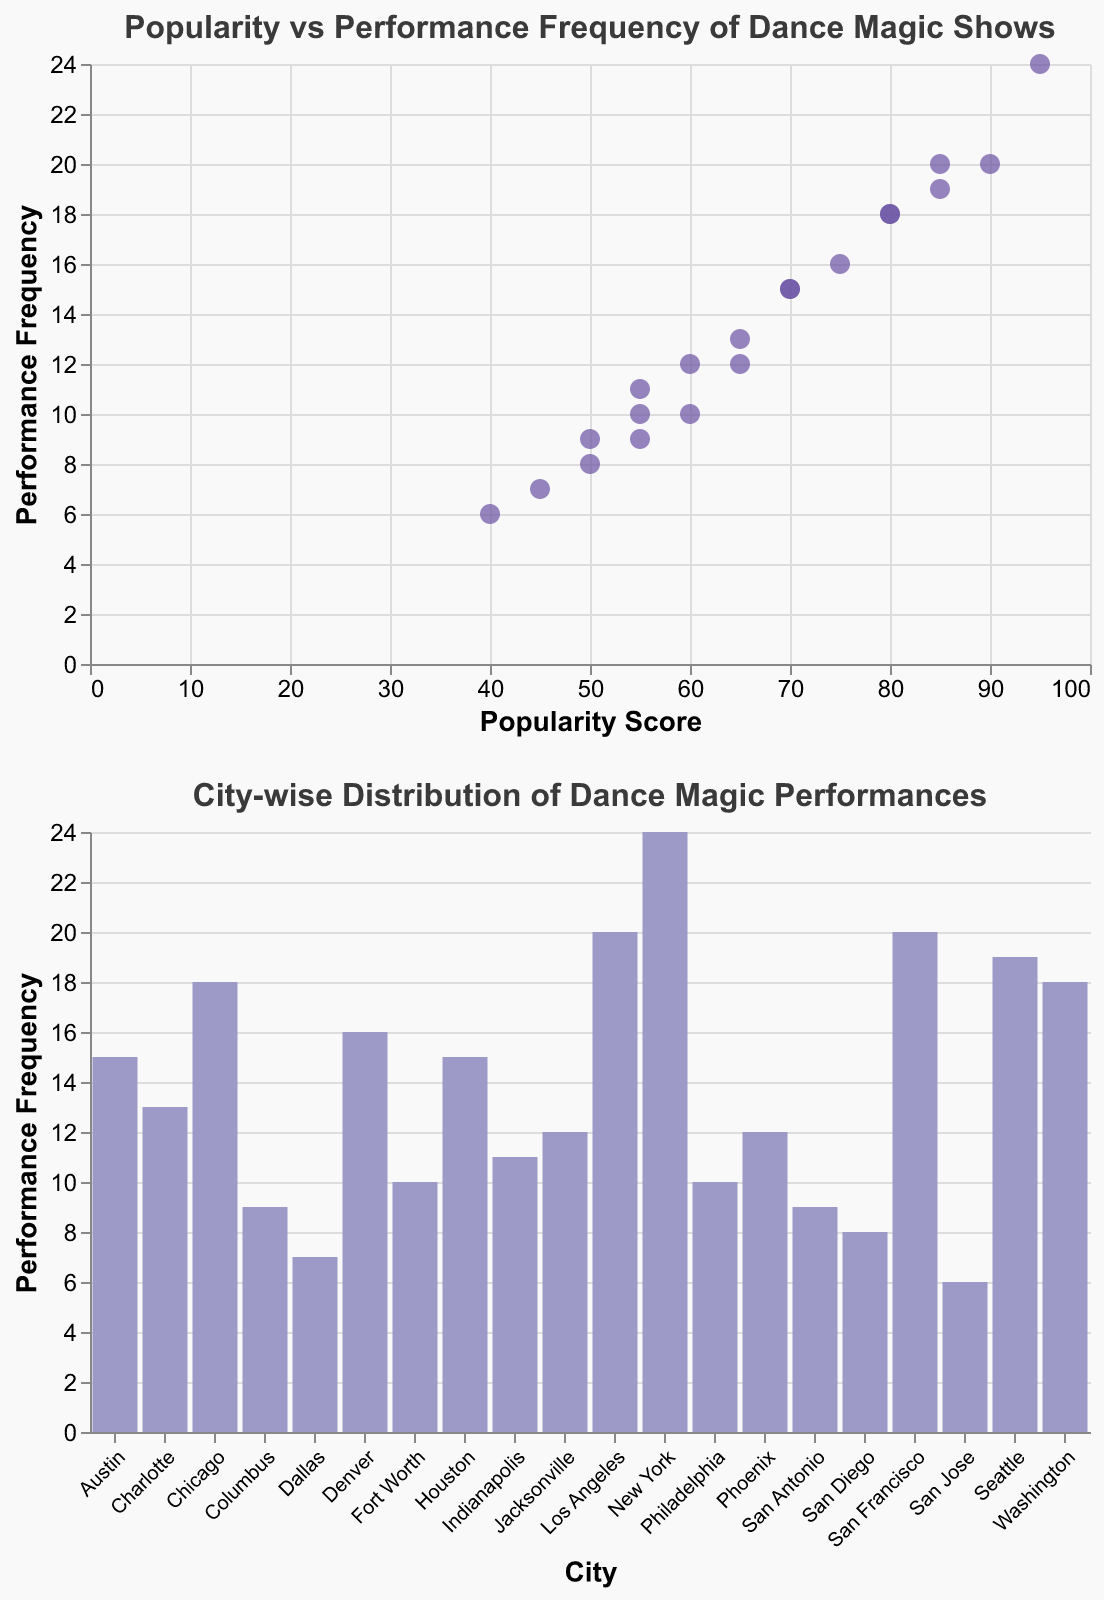What's the city with the highest popularity score? The scatter plot shows various cities with their corresponding popularity scores and performance frequencies. The highest popularity score visible is 95, which belongs to New York.
Answer: New York Which city has the most frequent performances? The city with the highest performance frequency can be identified from the scatter plot. The city reaching the highest y-axis value of 24 is New York.
Answer: New York How many cities have a performance frequency of less than 10? From the scatter plot, the cities with a performance frequency less than 10 are San Antonio, San Diego, Dallas, San Jose, and Columbus. Counting these gives a total of 5 cities.
Answer: 5 Which city has both a high popularity score and performance frequency but isn't the highest in either category? From the scatter plot, Seattle has a popularity score of 85 and a performance frequency of 19. While these values are high, they are not the highest in their respective categories.
Answer: Seattle What is the average performance frequency of cities having popularity scores above 80? Cities with popularity scores above 80 are New York (24), Los Angeles (20), San Francisco (20), Seattle (19), and Washington (18). Summing their frequencies: 24 + 20 + 20 + 19 + 18 = 101. The average is 101/5.
Answer: 20.2 Which city with a popularity score below 60 has the highest performance frequency? From the scatter plot or the table, Philadelphia has a popularity score of 60 with a performance frequency of 10. All other cities below 60 have lower frequencies.
Answer: Philadelphia Compare the performance frequencies of Austin and Denver. Which city has more performances? Austin has a performance frequency of 15, whereas Denver has a performance frequency of 16. Therefore, Denver has more performances.
Answer: Denver Which city with a popularity score of exactly 60 has more performances, Jacksonville or Philadelphia? Both cities have a popularity score of 60. Jacksonville has 12 performances, while Philadelphia has 10. Thus, Jacksonville has more performances.
Answer: Jacksonville How many cities have both a popularity score and performance frequency above 15? From the scatter plot, cities fulfilling both conditions can be identified as New York, Los Angeles, Chicago, San Francisco, Seattle, Denver, and Washington. Therefore, there are 7 such cities.
Answer: 7 